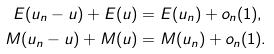Convert formula to latex. <formula><loc_0><loc_0><loc_500><loc_500>E ( u _ { n } - u ) + E ( u ) & = E ( u _ { n } ) + o _ { n } ( 1 ) , \\ M ( u _ { n } - u ) + M ( u ) & = M ( u _ { n } ) + o _ { n } ( 1 ) .</formula> 